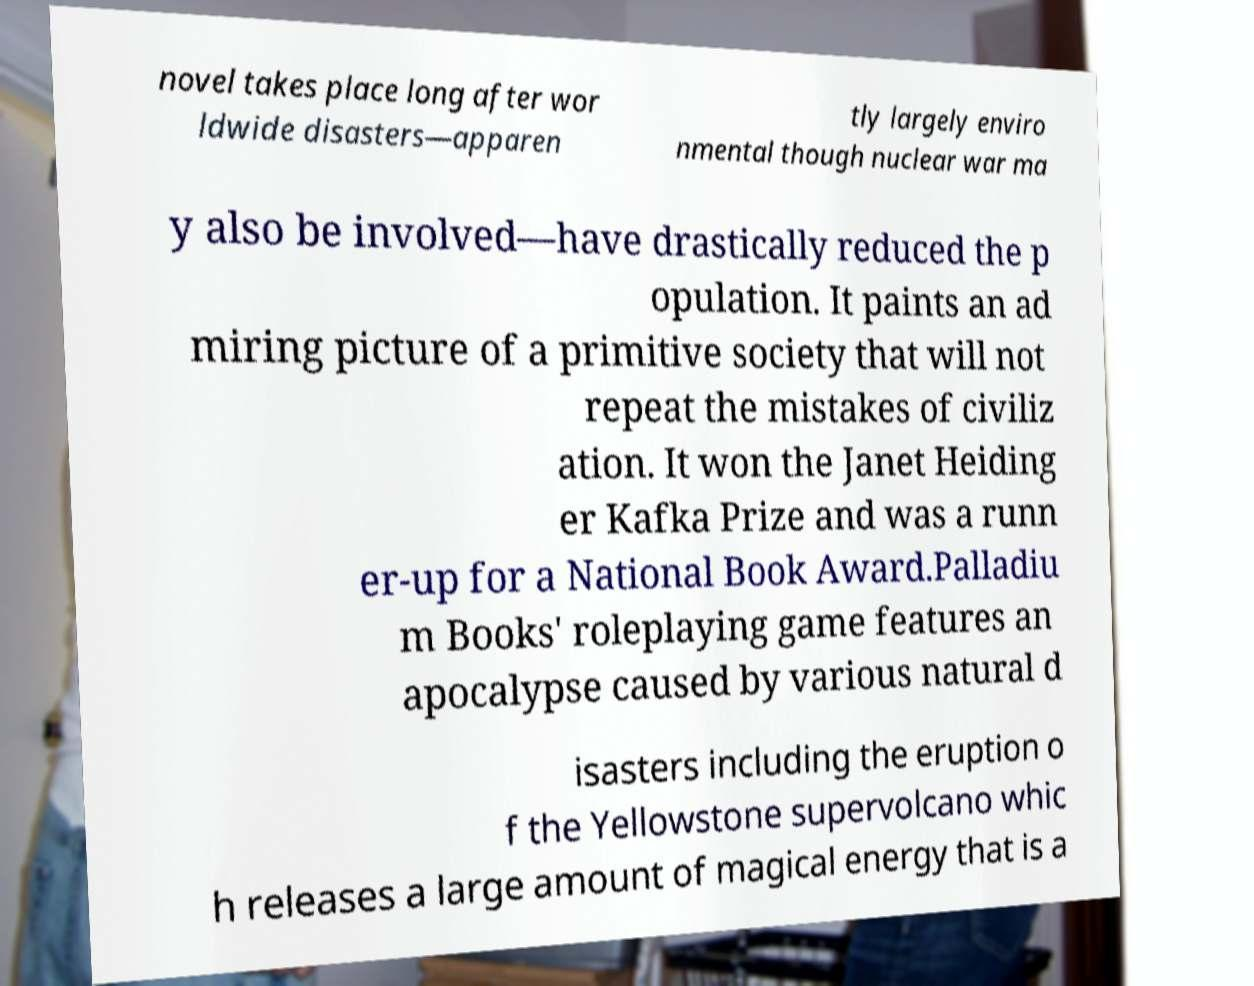Could you extract and type out the text from this image? novel takes place long after wor ldwide disasters—apparen tly largely enviro nmental though nuclear war ma y also be involved—have drastically reduced the p opulation. It paints an ad miring picture of a primitive society that will not repeat the mistakes of civiliz ation. It won the Janet Heiding er Kafka Prize and was a runn er-up for a National Book Award.Palladiu m Books' roleplaying game features an apocalypse caused by various natural d isasters including the eruption o f the Yellowstone supervolcano whic h releases a large amount of magical energy that is a 